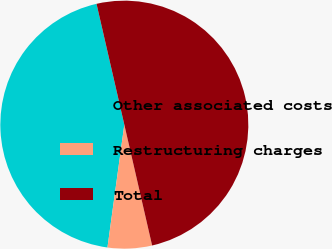<chart> <loc_0><loc_0><loc_500><loc_500><pie_chart><fcel>Other associated costs<fcel>Restructuring charges<fcel>Total<nl><fcel>44.23%<fcel>5.77%<fcel>50.0%<nl></chart> 